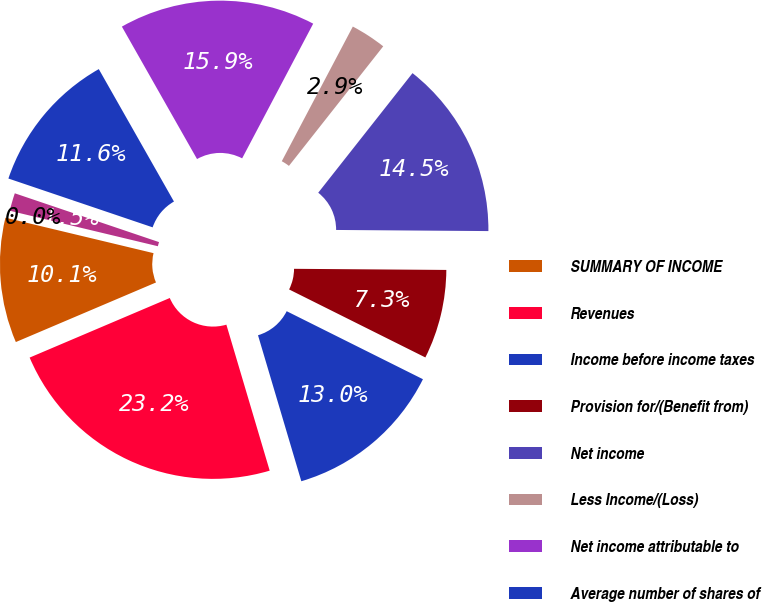<chart> <loc_0><loc_0><loc_500><loc_500><pie_chart><fcel>SUMMARY OF INCOME<fcel>Revenues<fcel>Income before income taxes<fcel>Provision for/(Benefit from)<fcel>Net income<fcel>Less Income/(Loss)<fcel>Net income attributable to<fcel>Average number of shares of<fcel>Basic income<fcel>Diluted income<nl><fcel>10.14%<fcel>23.19%<fcel>13.04%<fcel>7.25%<fcel>14.49%<fcel>2.9%<fcel>15.94%<fcel>11.59%<fcel>1.45%<fcel>0.0%<nl></chart> 